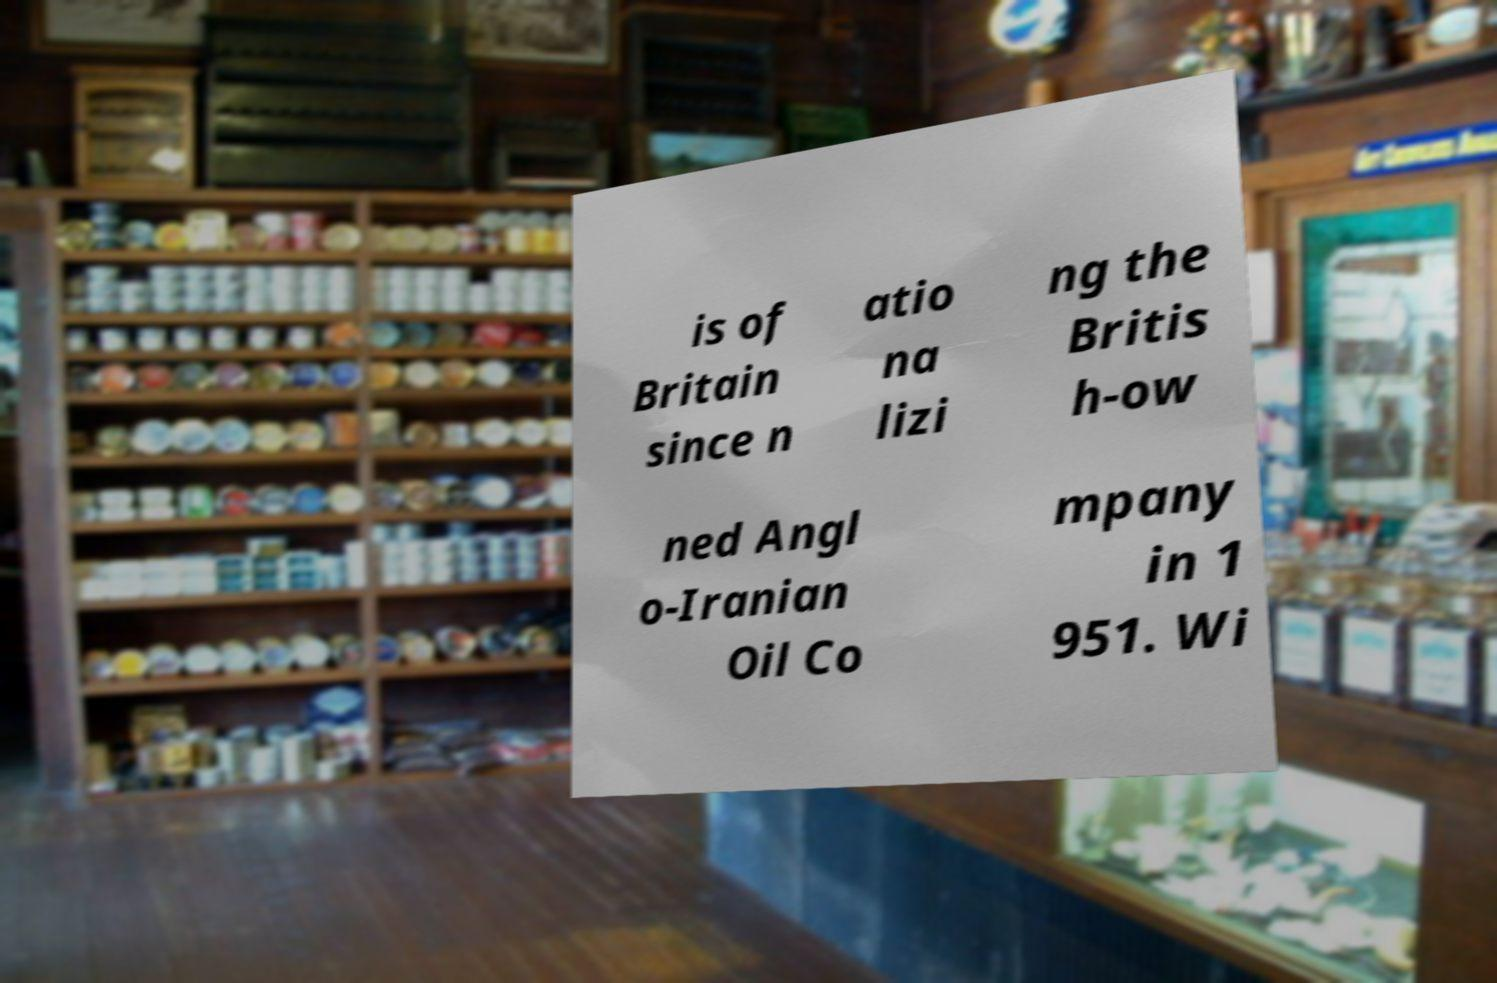Can you accurately transcribe the text from the provided image for me? is of Britain since n atio na lizi ng the Britis h-ow ned Angl o-Iranian Oil Co mpany in 1 951. Wi 